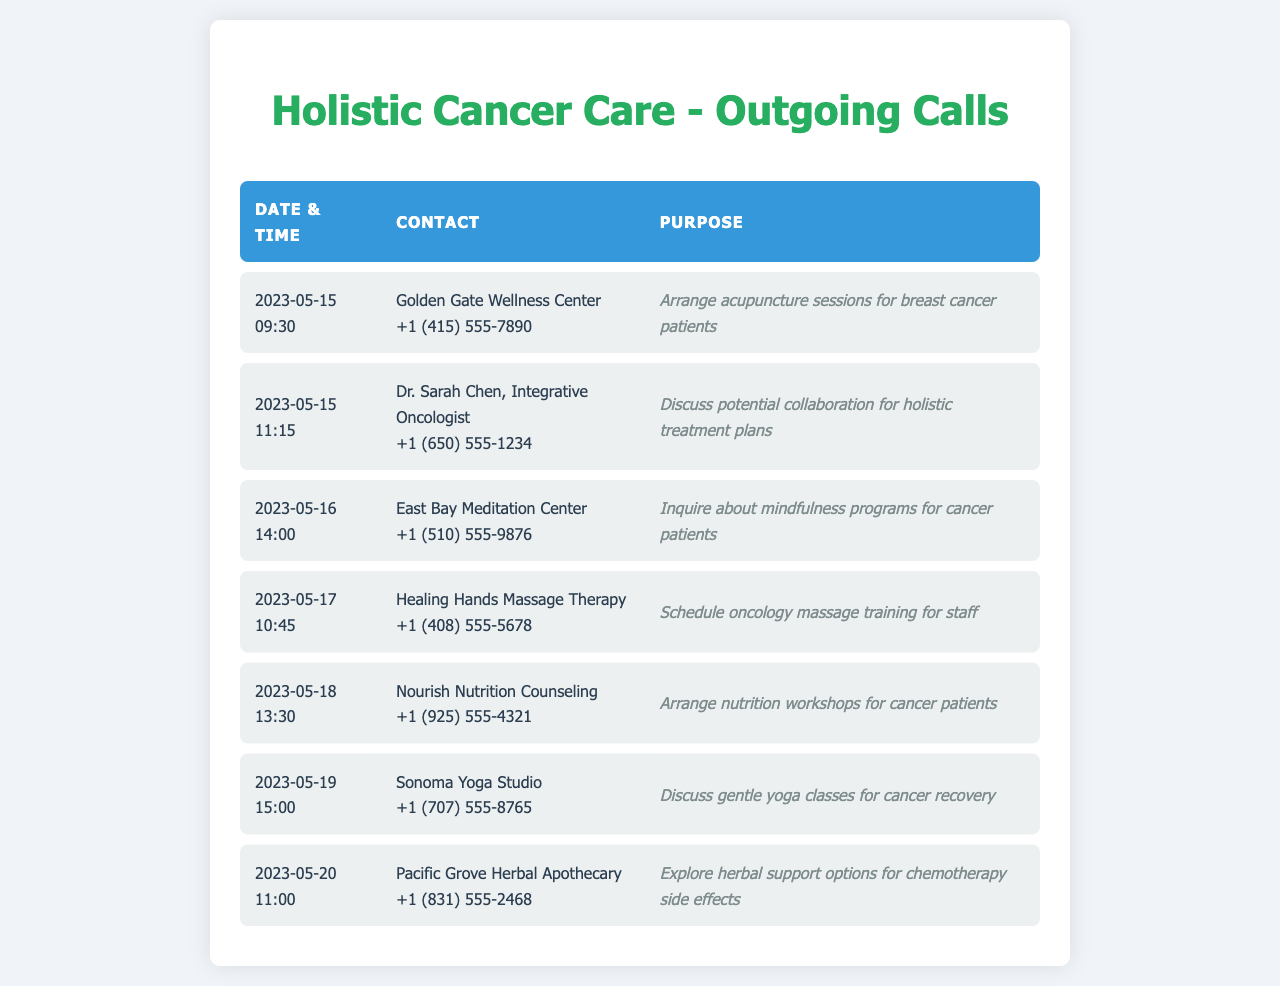What is the purpose of the call made to Golden Gate Wellness Center? The purpose of the call is to arrange acupuncture sessions for breast cancer patients.
Answer: Arrange acupuncture sessions for breast cancer patients What date was the call to Dr. Sarah Chen, Integrative Oncologist, made? The call to Dr. Sarah Chen was made on May 15, 2023.
Answer: 2023-05-15 Which wellness center was contacted to inquire about mindfulness programs? The East Bay Meditation Center was contacted for this purpose.
Answer: East Bay Meditation Center How many calls were made to explore food and nutrition options? There was one call made to arrange nutrition workshops for cancer patients.
Answer: One What kind of training was scheduled with Healing Hands Massage Therapy? The training scheduled was oncology massage training for staff.
Answer: Oncology massage training What time was the call to Sonoma Yoga Studio made? The call to Sonoma Yoga Studio was made at 3:00 PM on May 19, 2023.
Answer: 15:00 Which holistic practitioner was contacted on May 20, 2023? Pacific Grove Herbal Apothecary was contacted on that date.
Answer: Pacific Grove Herbal Apothecary 